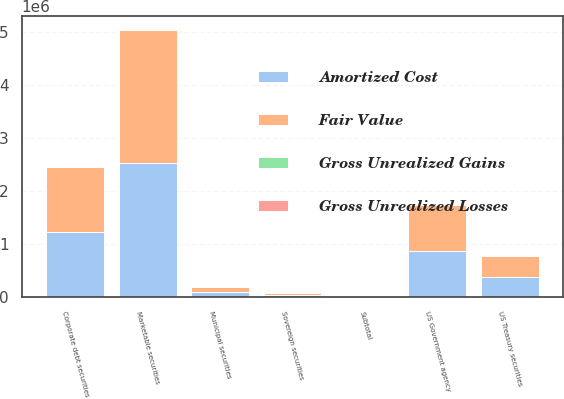Convert chart. <chart><loc_0><loc_0><loc_500><loc_500><stacked_bar_chart><ecel><fcel>US Treasury securities<fcel>US Government agency<fcel>Municipal securities<fcel>Corporate debt securities<fcel>Sovereign securities<fcel>Subtotal<fcel>Marketable securities<nl><fcel>Fair Value<fcel>384165<fcel>867309<fcel>96198<fcel>1.22079e+06<fcel>42227<fcel>4603<fcel>2.51757e+06<nl><fcel>Gross Unrealized Gains<fcel>287<fcel>651<fcel>93<fcel>3526<fcel>46<fcel>4603<fcel>4603<nl><fcel>Gross Unrealized Losses<fcel>52<fcel>117<fcel>75<fcel>152<fcel>9<fcel>405<fcel>397<nl><fcel>Amortized Cost<fcel>384400<fcel>867843<fcel>96216<fcel>1.22417e+06<fcel>42264<fcel>4603<fcel>2.52178e+06<nl></chart> 